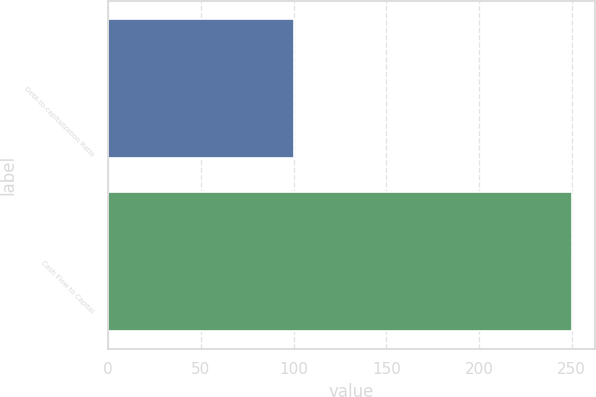Convert chart to OTSL. <chart><loc_0><loc_0><loc_500><loc_500><bar_chart><fcel>Debt-to-capitalization Ratio<fcel>Cash Flow to Capital<nl><fcel>100<fcel>250<nl></chart> 